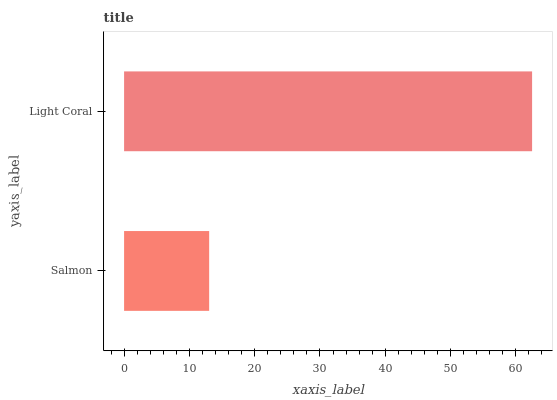Is Salmon the minimum?
Answer yes or no. Yes. Is Light Coral the maximum?
Answer yes or no. Yes. Is Light Coral the minimum?
Answer yes or no. No. Is Light Coral greater than Salmon?
Answer yes or no. Yes. Is Salmon less than Light Coral?
Answer yes or no. Yes. Is Salmon greater than Light Coral?
Answer yes or no. No. Is Light Coral less than Salmon?
Answer yes or no. No. Is Light Coral the high median?
Answer yes or no. Yes. Is Salmon the low median?
Answer yes or no. Yes. Is Salmon the high median?
Answer yes or no. No. Is Light Coral the low median?
Answer yes or no. No. 